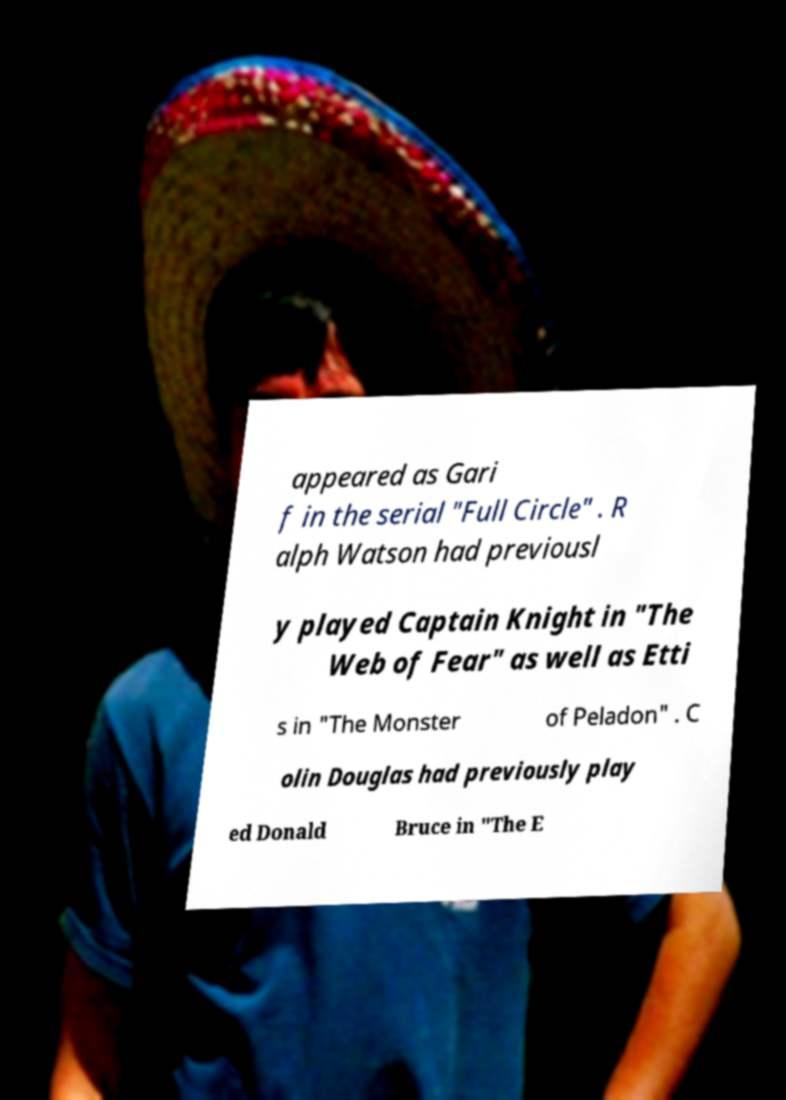I need the written content from this picture converted into text. Can you do that? appeared as Gari f in the serial "Full Circle" . R alph Watson had previousl y played Captain Knight in "The Web of Fear" as well as Etti s in "The Monster of Peladon" . C olin Douglas had previously play ed Donald Bruce in "The E 